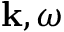<formula> <loc_0><loc_0><loc_500><loc_500>{ k } , \omega</formula> 